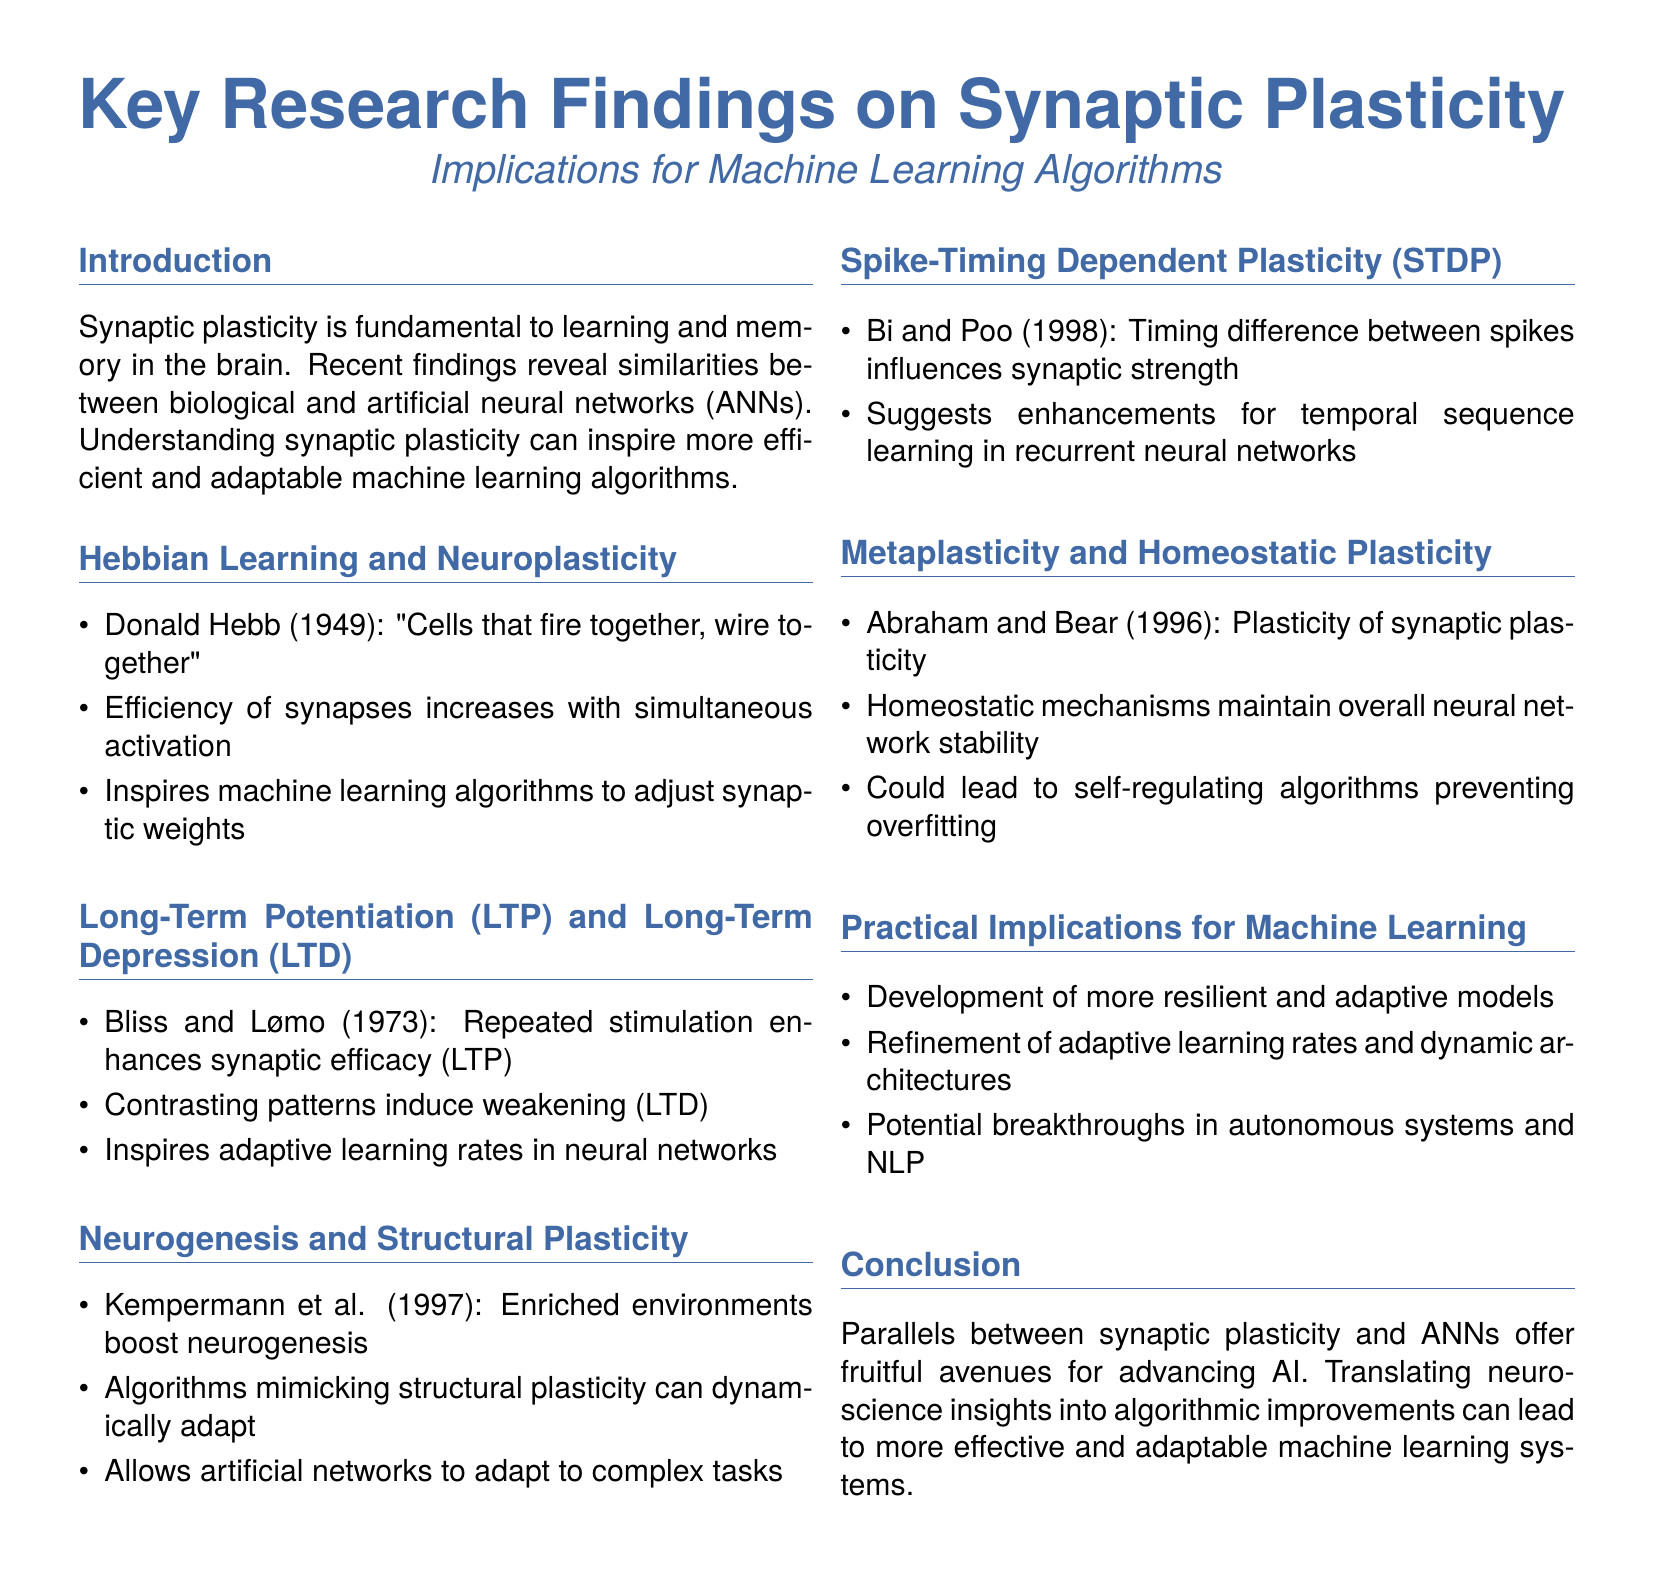What did Donald Hebb state in 1949? Donald Hebb's quote highlights the principle that simultaneous activation of cells strengthens their connection, leading to the phrase "Cells that fire together, wire together."
Answer: "Cells that fire together, wire together" What enhances synaptic efficacy according to Bliss and Lømo? Bliss and Lømo's findings indicate that repeated stimulation improves synaptic efficacy, a phenomenon known as long-term potentiation (LTP).
Answer: LTP What environmental condition boosts neurogenesis? The document states that enriched environments contribute positively to neurogenesis according to Kempermann et al.
Answer: Enriched environments Who conducted significant research on spike-timing dependent plasticity? The study of spike-timing dependent plasticity is attributed to Bi and Poo in 1998.
Answer: Bi and Poo What concept describes the stability-maintaining mechanisms in neural networks? The term for mechanisms that maintain stability in neural networks is homeostatic plasticity, as described by Abraham and Bear.
Answer: Homeostatic plasticity What practical implications are mentioned for machine learning? The document outlines that advancements in resilience and adaptability of models represent practical implications for machine learning.
Answer: Resilience and adaptability How does the concept of metaplasticity relate to synaptic plasticity? Metaplasticity refers to the plasticity of synaptic plasticity itself, providing insight into changes in plasticity mechanisms.
Answer: Plasticity of synaptic plasticity What potential advancements in AI methods are hinted at in the conclusion? The conclusion suggests that translating neuroscience insights can lead to breakthroughs in artificial intelligence systems.
Answer: Breakthroughs in AI What type of learning rates are inspired by LTP and LTD findings? The learning rates adjusted by the concepts of LTP and LTD are adaptive learning rates as inspired by these phenomena.
Answer: Adaptive learning rates 